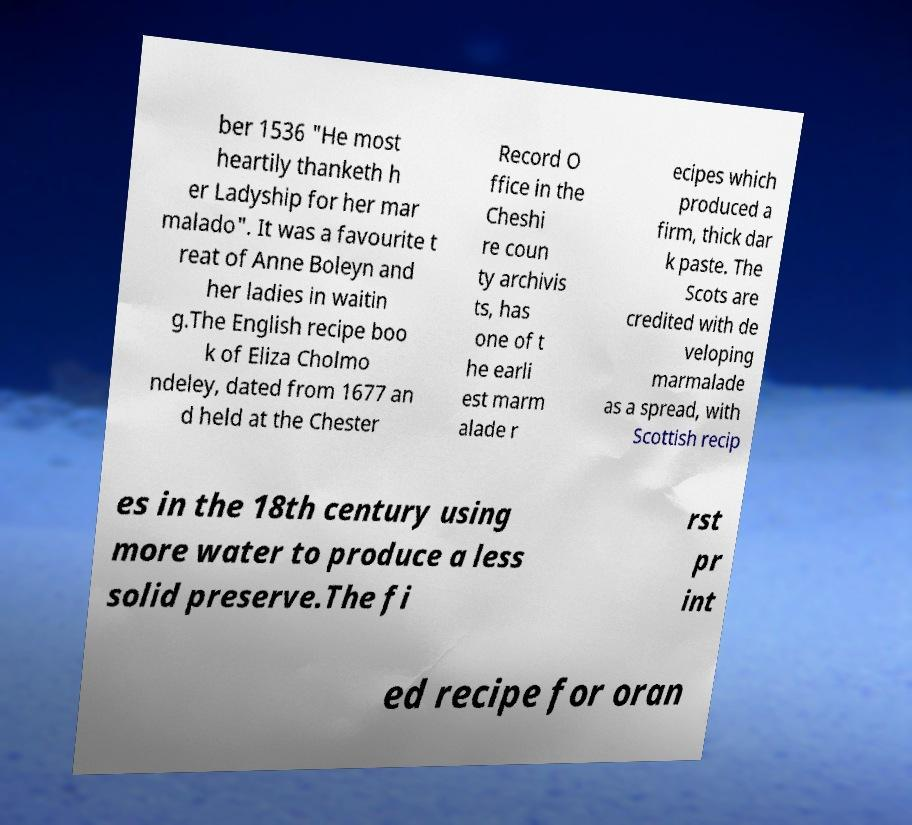I need the written content from this picture converted into text. Can you do that? ber 1536 "He most heartily thanketh h er Ladyship for her mar malado". It was a favourite t reat of Anne Boleyn and her ladies in waitin g.The English recipe boo k of Eliza Cholmo ndeley, dated from 1677 an d held at the Chester Record O ffice in the Cheshi re coun ty archivis ts, has one of t he earli est marm alade r ecipes which produced a firm, thick dar k paste. The Scots are credited with de veloping marmalade as a spread, with Scottish recip es in the 18th century using more water to produce a less solid preserve.The fi rst pr int ed recipe for oran 